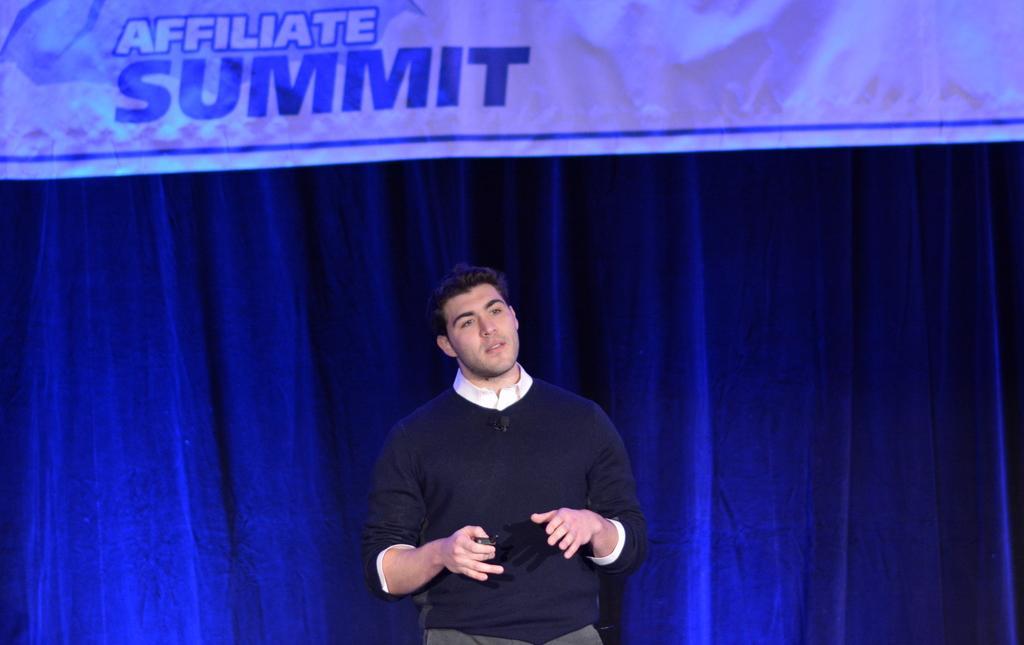In one or two sentences, can you explain what this image depicts? In this image we can see a man standing and holding an object in his hand and in the background, we can see a curtain and there is a banner with some text. 